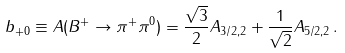<formula> <loc_0><loc_0><loc_500><loc_500>b _ { + 0 } \equiv A ( B ^ { + } \to \pi ^ { + } \pi ^ { 0 } ) = \frac { \sqrt { 3 } } { 2 } A _ { 3 / 2 , 2 } + \frac { 1 } { \sqrt { 2 } } A _ { 5 / 2 , 2 } \, .</formula> 